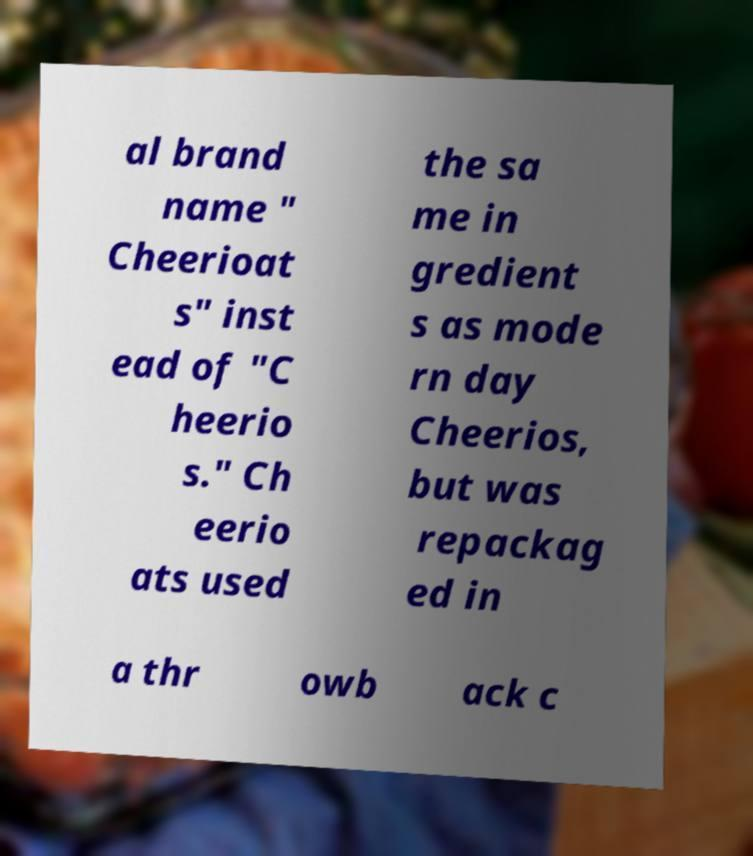What messages or text are displayed in this image? I need them in a readable, typed format. al brand name " Cheerioat s" inst ead of "C heerio s." Ch eerio ats used the sa me in gredient s as mode rn day Cheerios, but was repackag ed in a thr owb ack c 